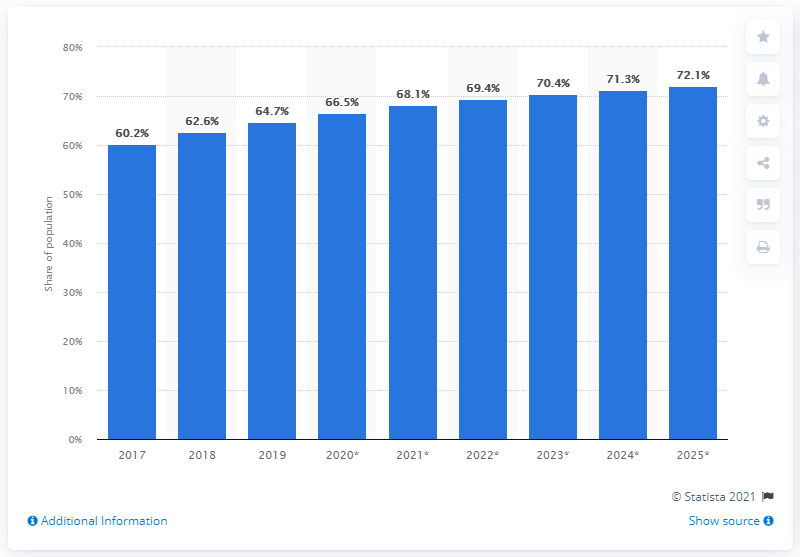Mention a couple of crucial points in this snapshot. It is projected that by 2025, the use of Facebook will increase by 72.1%. 